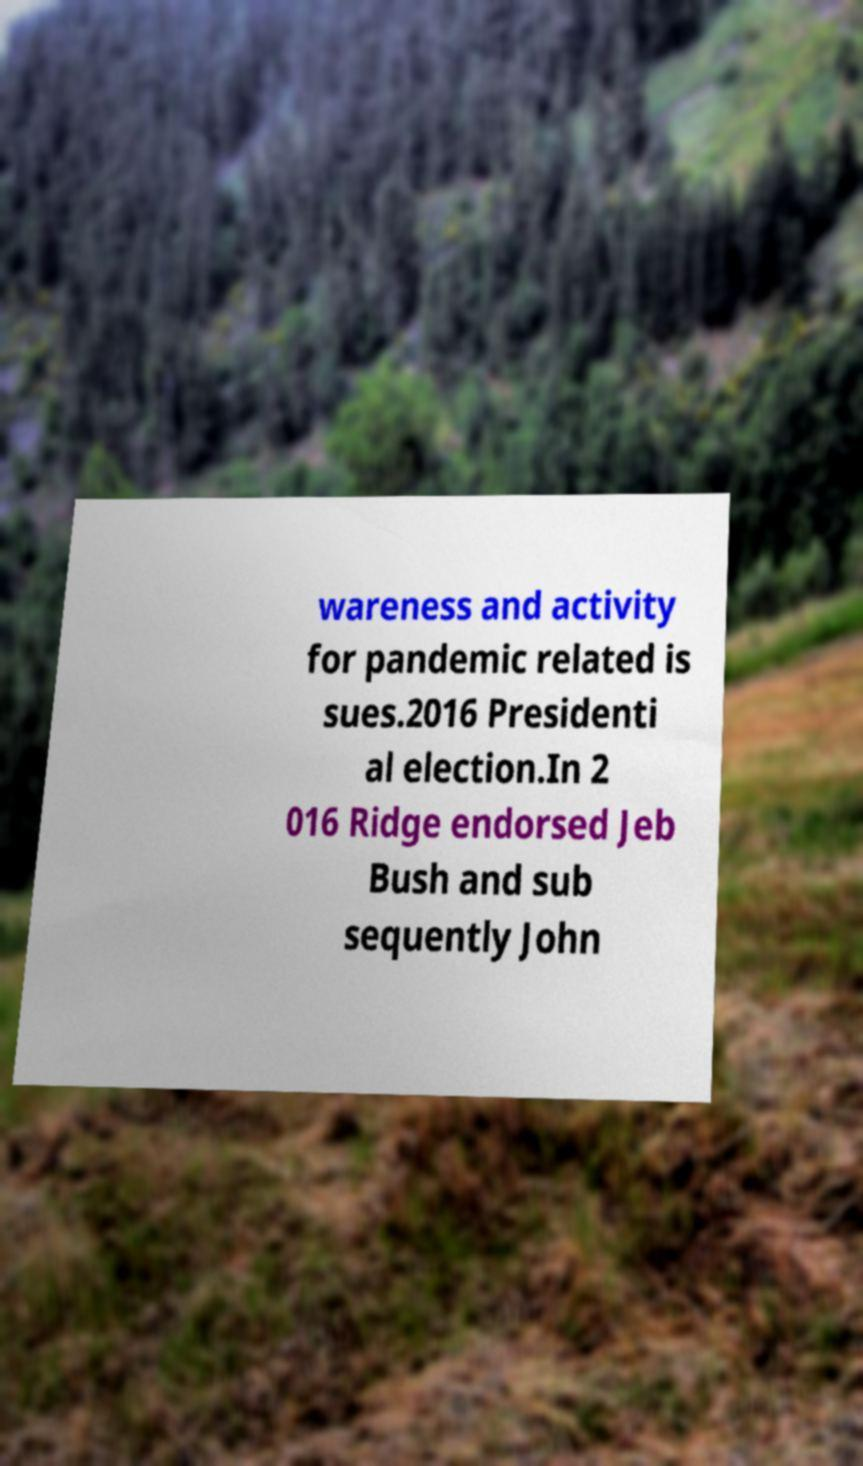Please read and relay the text visible in this image. What does it say? wareness and activity for pandemic related is sues.2016 Presidenti al election.In 2 016 Ridge endorsed Jeb Bush and sub sequently John 